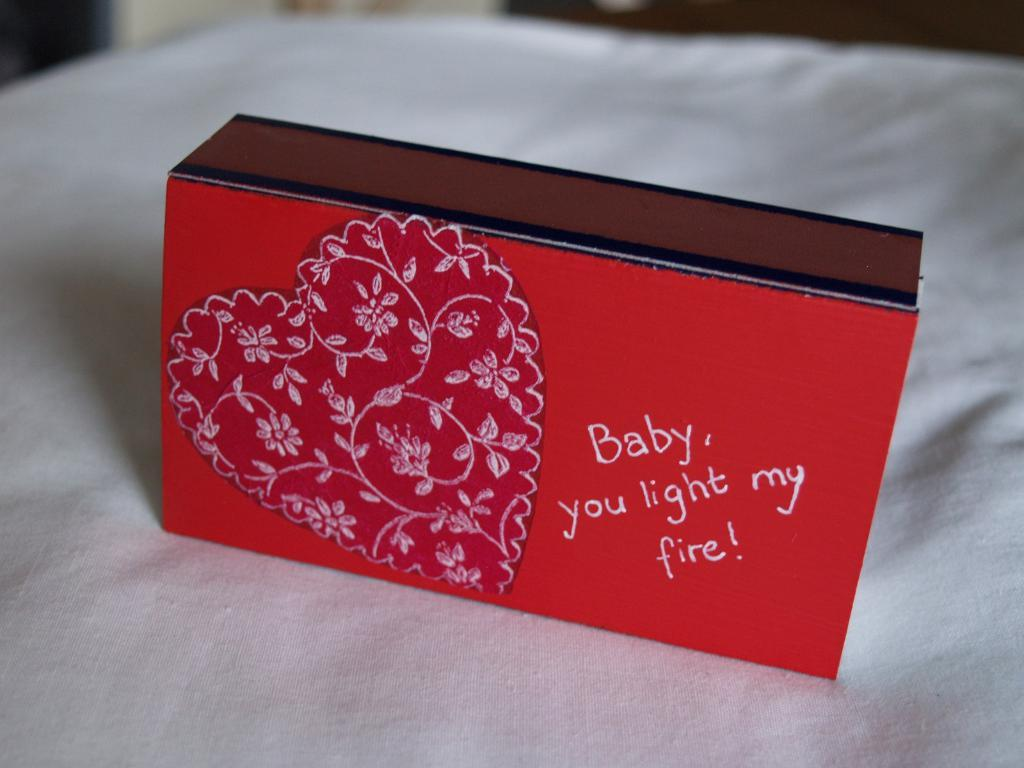<image>
Write a terse but informative summary of the picture. A box with a heart on it that says "Baby you light my fire". 